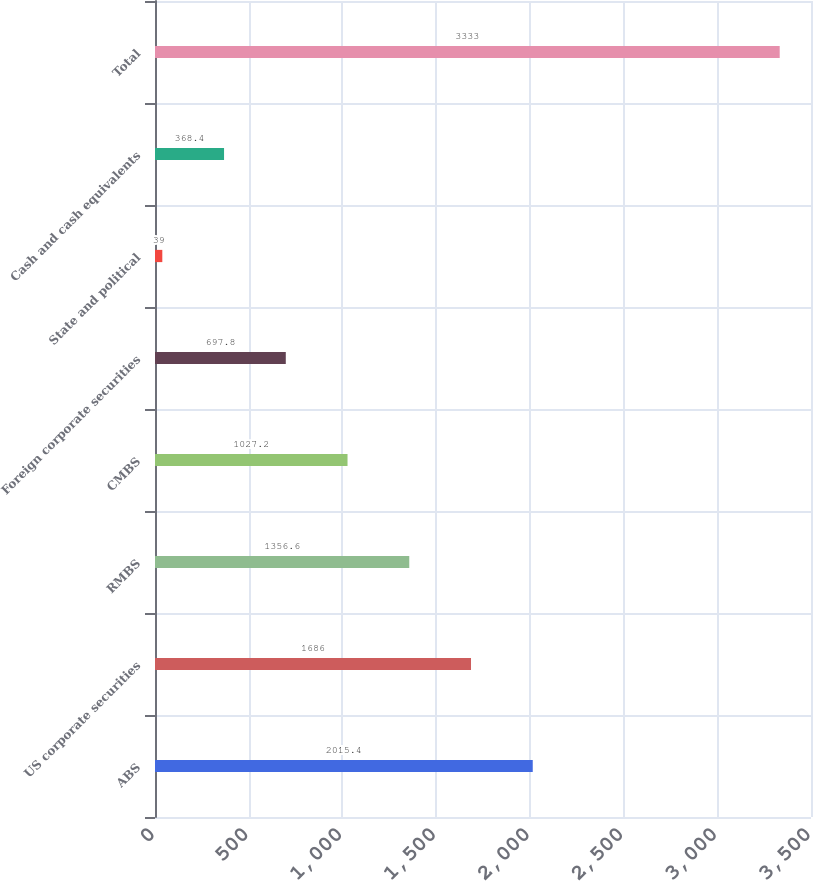<chart> <loc_0><loc_0><loc_500><loc_500><bar_chart><fcel>ABS<fcel>US corporate securities<fcel>RMBS<fcel>CMBS<fcel>Foreign corporate securities<fcel>State and political<fcel>Cash and cash equivalents<fcel>Total<nl><fcel>2015.4<fcel>1686<fcel>1356.6<fcel>1027.2<fcel>697.8<fcel>39<fcel>368.4<fcel>3333<nl></chart> 